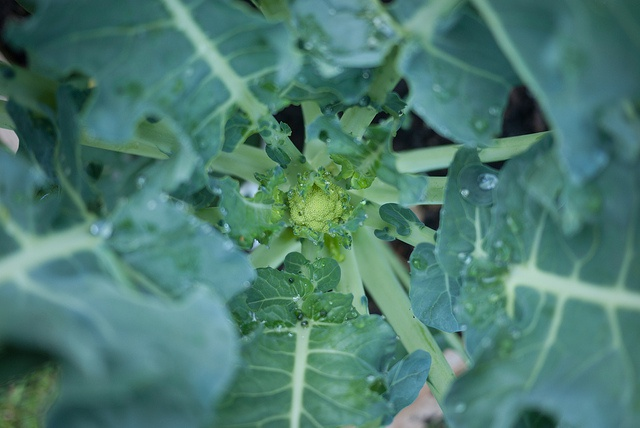Describe the objects in this image and their specific colors. I can see a broccoli in black, green, and lightgreen tones in this image. 